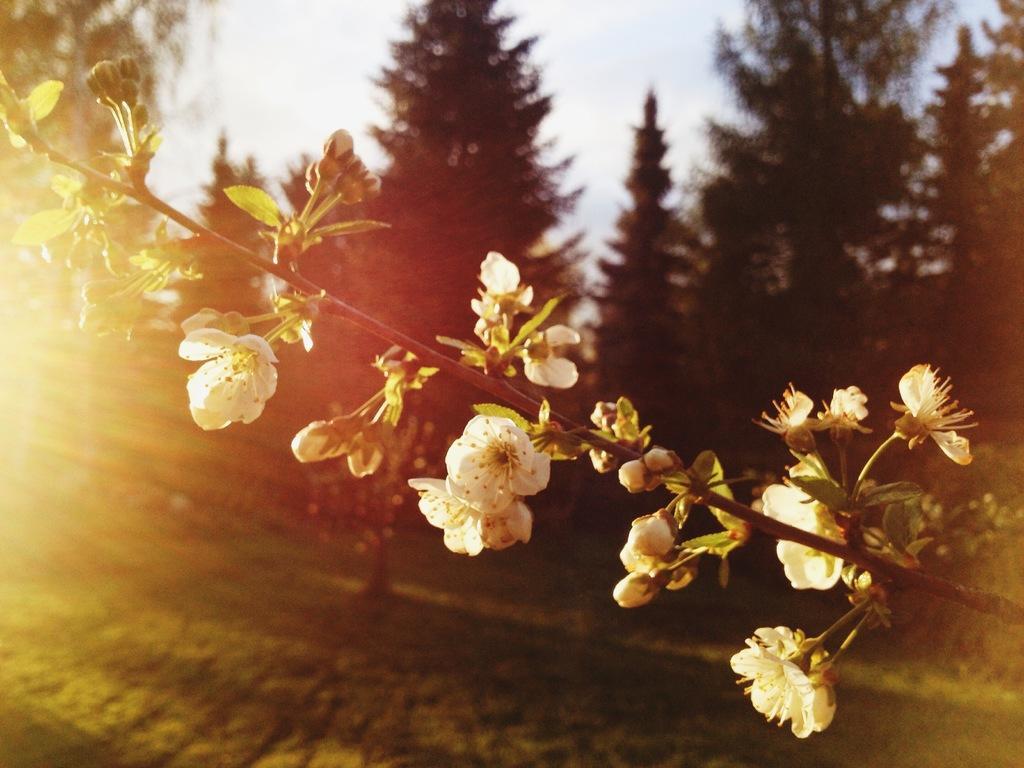How would you summarize this image in a sentence or two? This image consists of flowers in white color. At the bottom, there is green grass. In the background, there are many trees. At the top, there is a sky. 